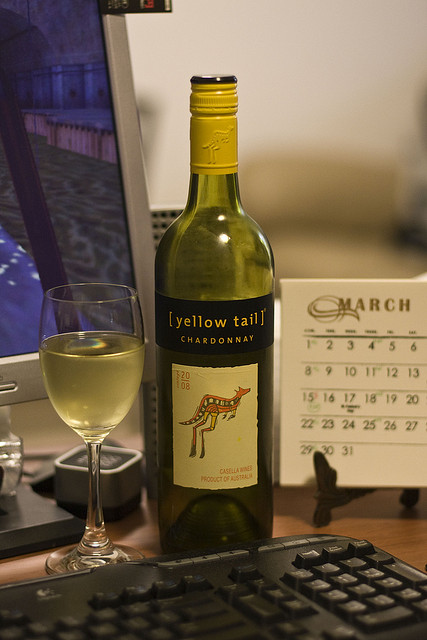<image>What brand of drink is this? I am not sure what brand of drink is this. It could possibly be 'yellow tail'. What brand of drink is this? I am not sure what brand of drink it is. However, it can be seen as 'yellow tail' or 'wine'. 